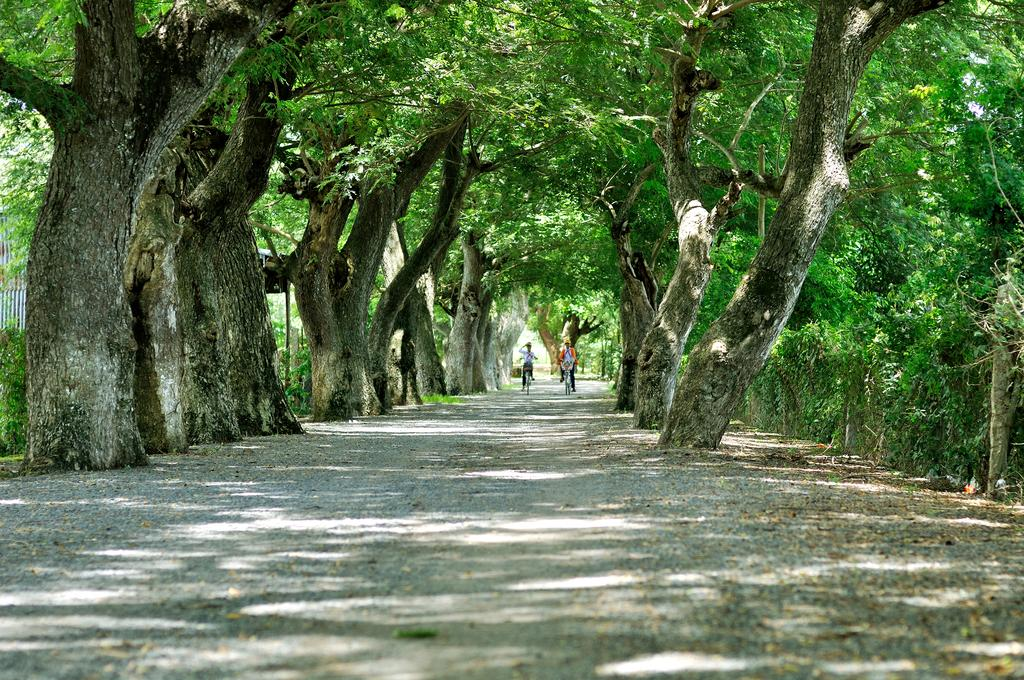How many people are in the image? There are two people in the image. What are the people doing in the image? The people are riding bicycles. What can be seen on both sides of the path in the image? There are trees on both sides of the path in the image. What type of string is being used to tie the bicycles together in the image? There is no string or any indication of the bicycles being tied together in the image. 